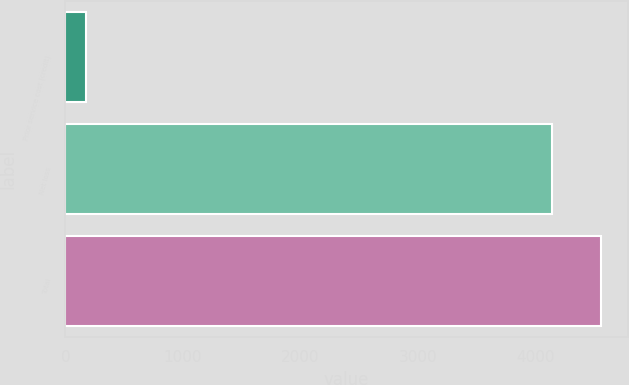<chart> <loc_0><loc_0><loc_500><loc_500><bar_chart><fcel>Prior service cost (credit)<fcel>Net loss<fcel>Total<nl><fcel>178<fcel>4146<fcel>4560.6<nl></chart> 